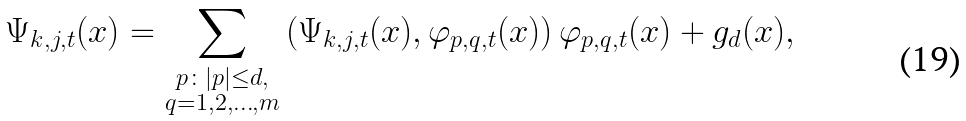Convert formula to latex. <formula><loc_0><loc_0><loc_500><loc_500>\Psi _ { k , j , t } ( x ) = \sum _ { \substack { p \colon | p | \leq d , \\ q = 1 , 2 , \dots , m } } \left ( \Psi _ { k , j , t } ( x ) , \varphi _ { p , q , t } ( x ) \right ) \varphi _ { p , q , t } ( x ) + g _ { d } ( x ) ,</formula> 